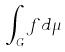Convert formula to latex. <formula><loc_0><loc_0><loc_500><loc_500>\int _ { G } f d \mu</formula> 